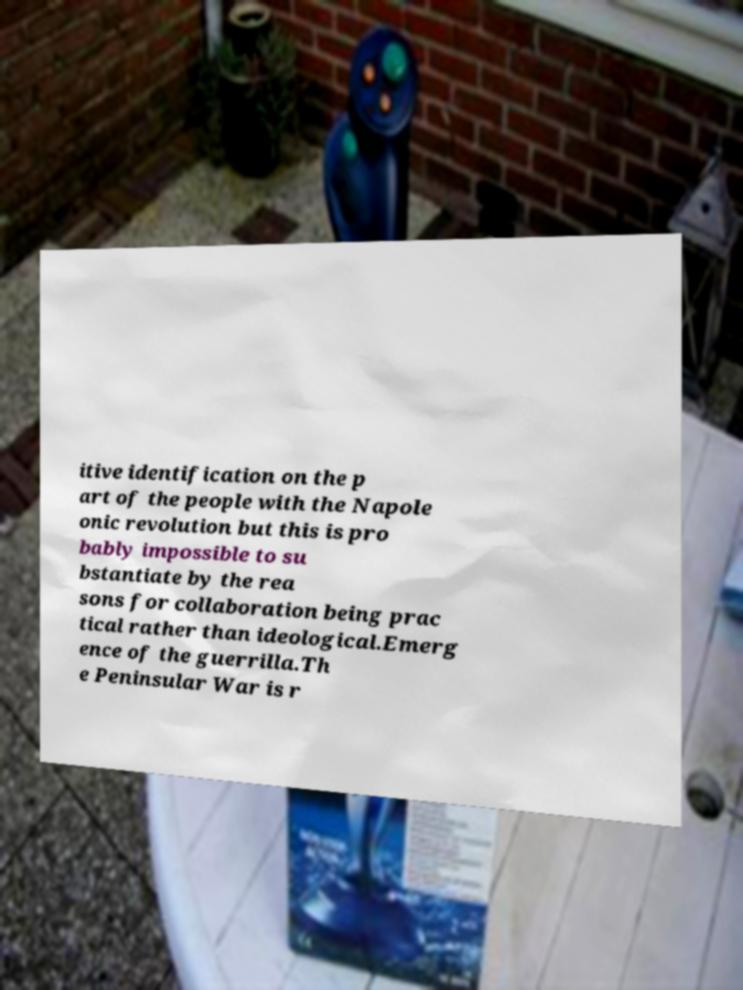I need the written content from this picture converted into text. Can you do that? itive identification on the p art of the people with the Napole onic revolution but this is pro bably impossible to su bstantiate by the rea sons for collaboration being prac tical rather than ideological.Emerg ence of the guerrilla.Th e Peninsular War is r 